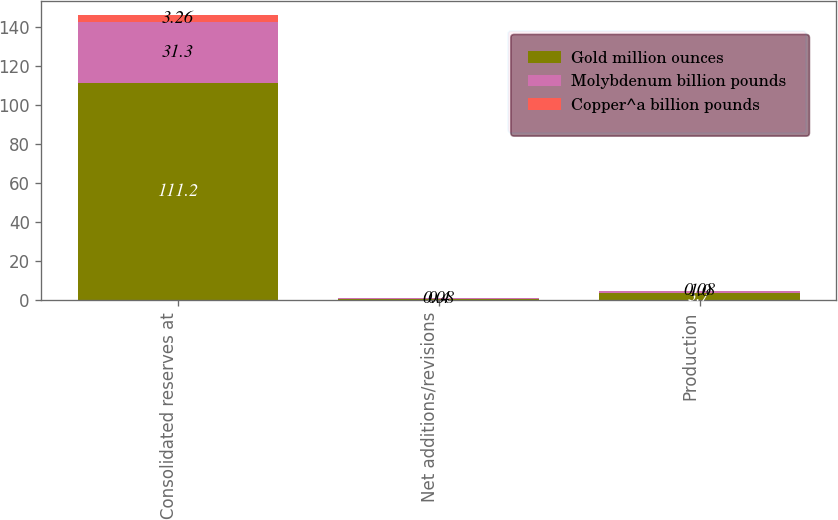Convert chart to OTSL. <chart><loc_0><loc_0><loc_500><loc_500><stacked_bar_chart><ecel><fcel>Consolidated reserves at<fcel>Net additions/revisions<fcel>Production<nl><fcel>Gold million ounces<fcel>111.2<fcel>0.5<fcel>3.7<nl><fcel>Molybdenum billion pounds<fcel>31.3<fcel>0.4<fcel>1<nl><fcel>Copper^a billion pounds<fcel>3.26<fcel>0.08<fcel>0.08<nl></chart> 